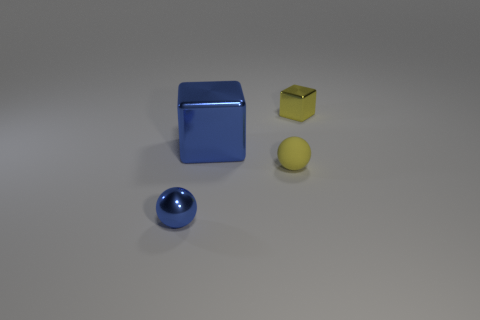Add 4 blue things. How many objects exist? 8 Subtract all blue shiny spheres. Subtract all small yellow shiny cubes. How many objects are left? 2 Add 4 yellow rubber things. How many yellow rubber things are left? 5 Add 1 large brown cubes. How many large brown cubes exist? 1 Subtract 0 yellow cylinders. How many objects are left? 4 